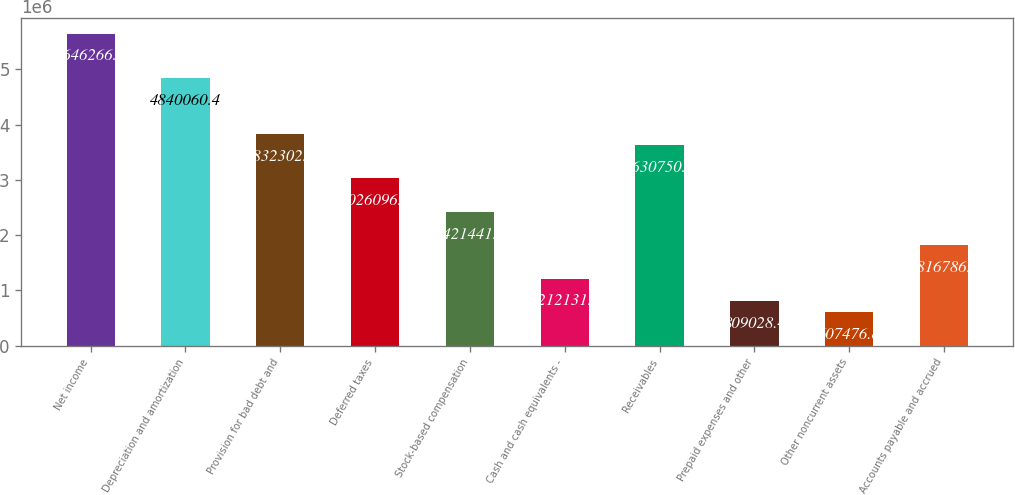<chart> <loc_0><loc_0><loc_500><loc_500><bar_chart><fcel>Net income<fcel>Depreciation and amortization<fcel>Provision for bad debt and<fcel>Deferred taxes<fcel>Stock-based compensation<fcel>Cash and cash equivalents -<fcel>Receivables<fcel>Prepaid expenses and other<fcel>Other noncurrent assets<fcel>Accounts payable and accrued<nl><fcel>5.64627e+06<fcel>4.84006e+06<fcel>3.8323e+06<fcel>3.0261e+06<fcel>2.42144e+06<fcel>1.21213e+06<fcel>3.63075e+06<fcel>809028<fcel>607477<fcel>1.81679e+06<nl></chart> 